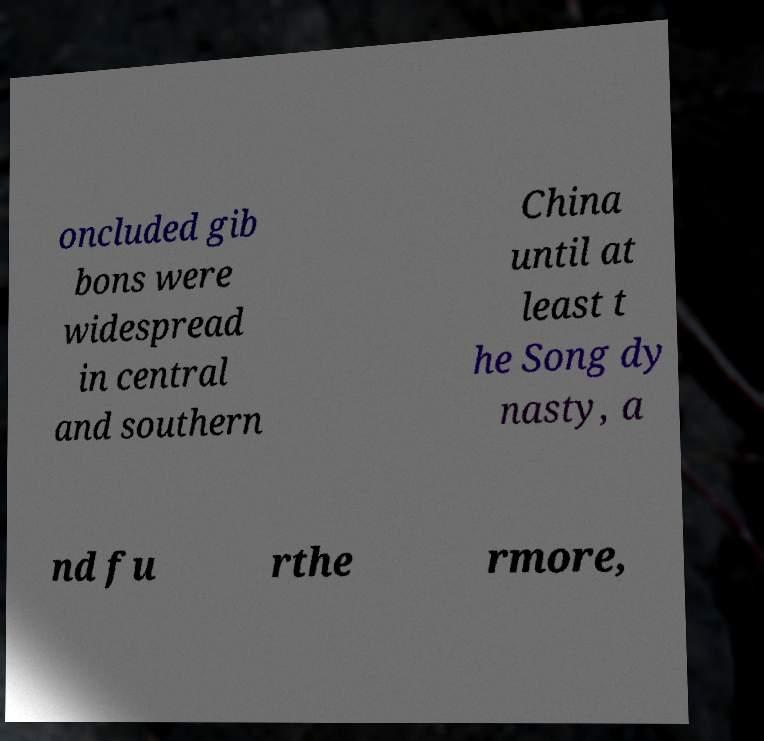Could you assist in decoding the text presented in this image and type it out clearly? oncluded gib bons were widespread in central and southern China until at least t he Song dy nasty, a nd fu rthe rmore, 